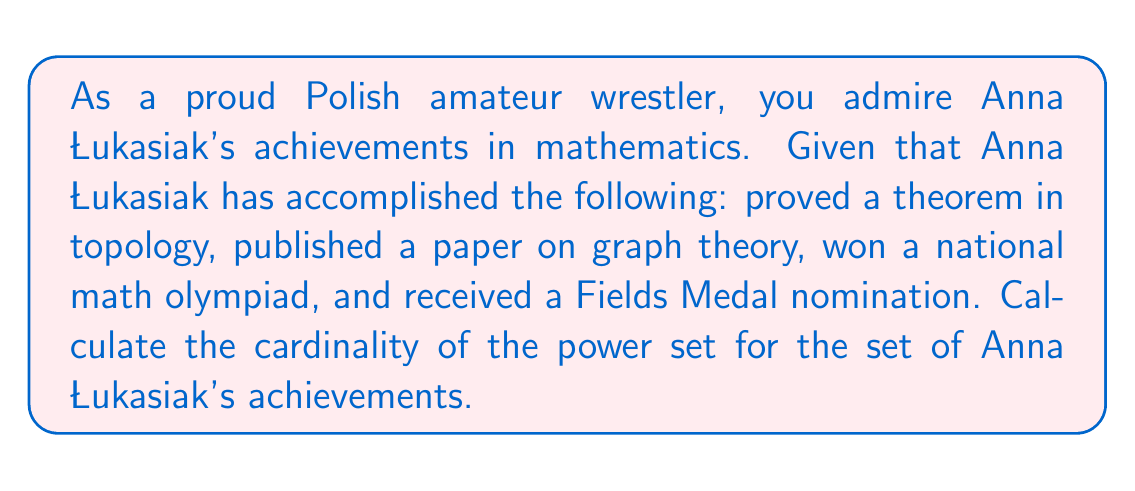What is the answer to this math problem? Let's approach this step-by-step:

1. First, we need to identify the set of Anna Łukasiak's achievements:
   $A = \{$ proved a theorem in topology, published a paper on graph theory, won a national math olympiad, received a Fields Medal nomination $\}$

2. We can see that the set $A$ has 4 elements. Let's call the number of elements in set $A$ as $n$. So, $n = 4$.

3. The power set of a set is the set of all possible subsets of that set, including the empty set and the set itself.

4. For a set with $n$ elements, the cardinality of its power set is given by the formula:

   $$ |P(A)| = 2^n $$

   Where $|P(A)|$ represents the cardinality of the power set of $A$.

5. In this case, we substitute $n = 4$ into the formula:

   $$ |P(A)| = 2^4 $$

6. Calculate:
   $$ |P(A)| = 2^4 = 2 \times 2 \times 2 \times 2 = 16 $$

Therefore, the cardinality of the power set of Anna Łukasiak's achievements is 16.
Answer: $|P(A)| = 16$ 